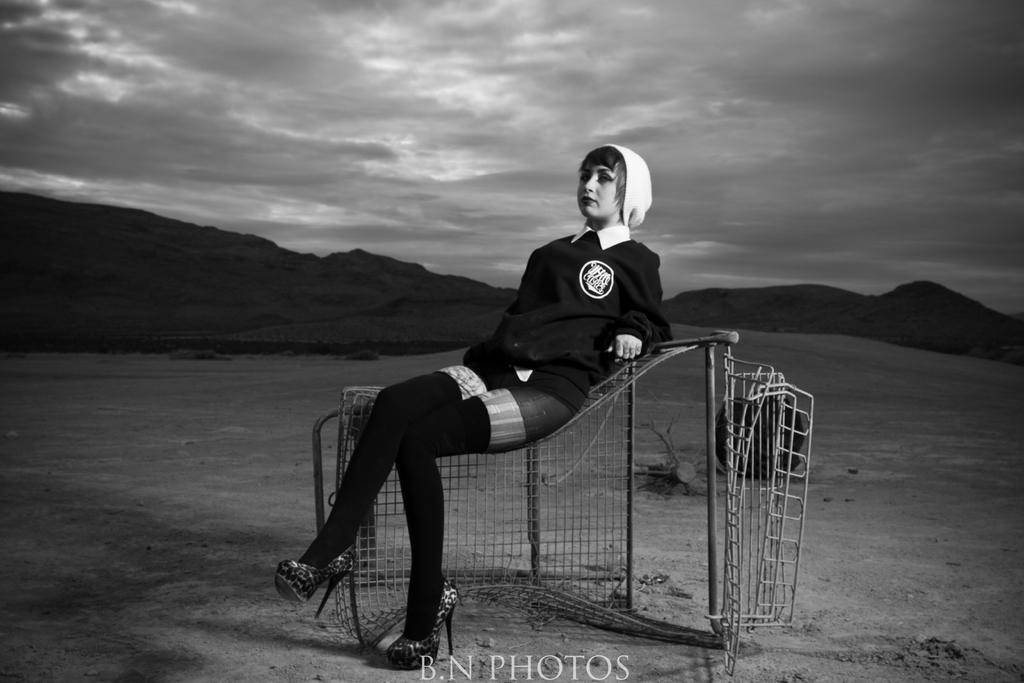Describe this image in one or two sentences. As we can see in the image there is a net, a woman wearing black color dress and sitting. In the background there are hills. At the top there is sky and clouds. 